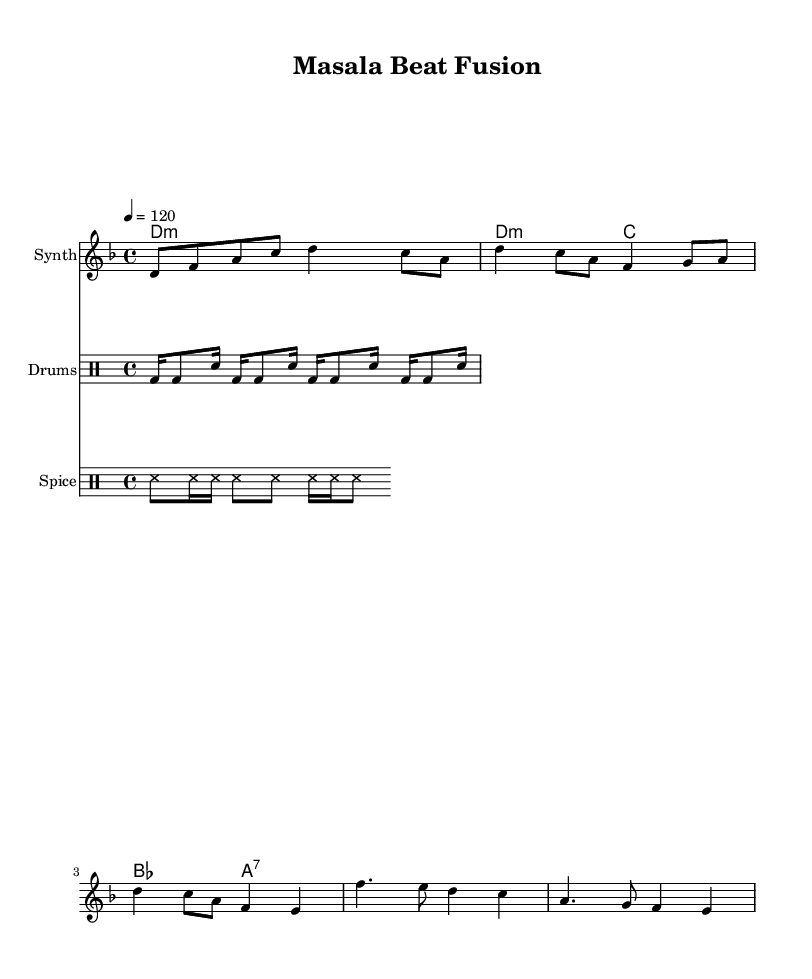What is the key signature of this music? The key signature is indicated in the global section of the code as "d minor," which has one flat (B flat) in its key signature.
Answer: d minor What is the time signature of the piece? The time signature is found in the global section also, marked as "4/4," which indicates four beats in each measure and a quarter note gets one beat.
Answer: 4/4 What is the tempo marking for this composition? The tempo markup is visible in the global section, written as "4 = 120," meaning the quarter note is set to be played at 120 beats per minute.
Answer: 120 How many different instruments are used in this piece? There are three distinct instrument parts noted in the score: one for "Synth," one for "Drums," and one for "Spice," resulting in a total of three instruments.
Answer: 3 What type of rhythms are incorporated in the spice shaker part? The spice shaker part consists of "ss8 ss16 ss ss8 ss ss16 ss ss8," revealing a combination of eighth and sixteenth note rhythms that create a unique texture.
Answer: Eighth and sixteenth Which section includes the main melodic theme? The main melodic theme can be identified in the "Verse" section, where the melody outlines a series of notes that define the theme of the piece.
Answer: Verse What is the function of the harmonies in this composition? The harmonies are defined as "d1:m d2:m c2 bes2 a2:7," indicating they serve to provide a harmonic foundation below the melody, enhancing its texture and depth.
Answer: Harmonic foundation 